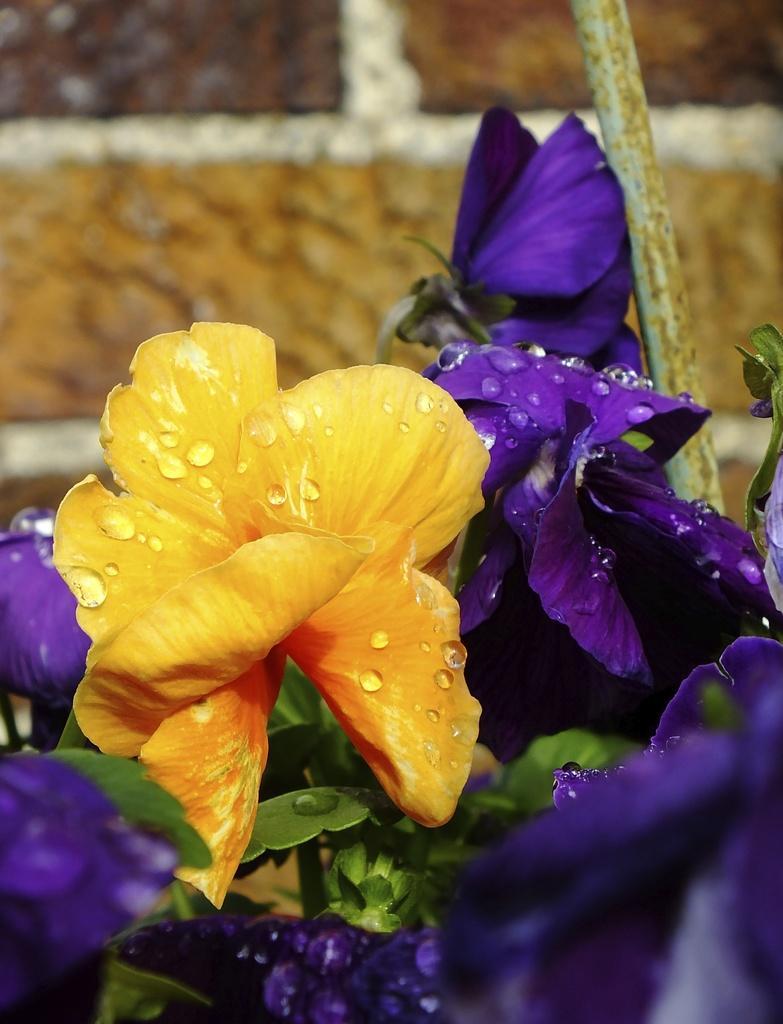In one or two sentences, can you explain what this image depicts? In this image, I can see the flowers, which are yellow and violet in color. On the right side of the image, I can see an iron rod. There is a blurred background. 